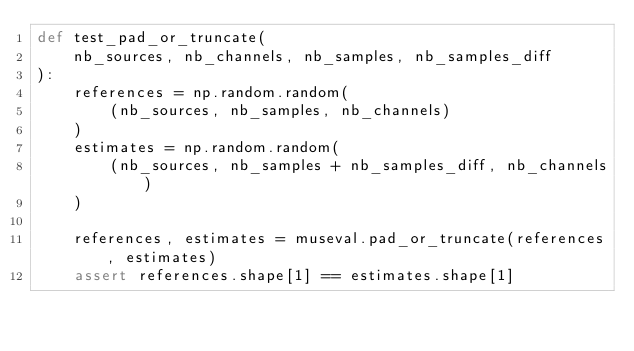<code> <loc_0><loc_0><loc_500><loc_500><_Python_>def test_pad_or_truncate(
    nb_sources, nb_channels, nb_samples, nb_samples_diff
):
    references = np.random.random(
        (nb_sources, nb_samples, nb_channels)
    )
    estimates = np.random.random(
        (nb_sources, nb_samples + nb_samples_diff, nb_channels)
    )

    references, estimates = museval.pad_or_truncate(references, estimates)
    assert references.shape[1] == estimates.shape[1]
</code> 